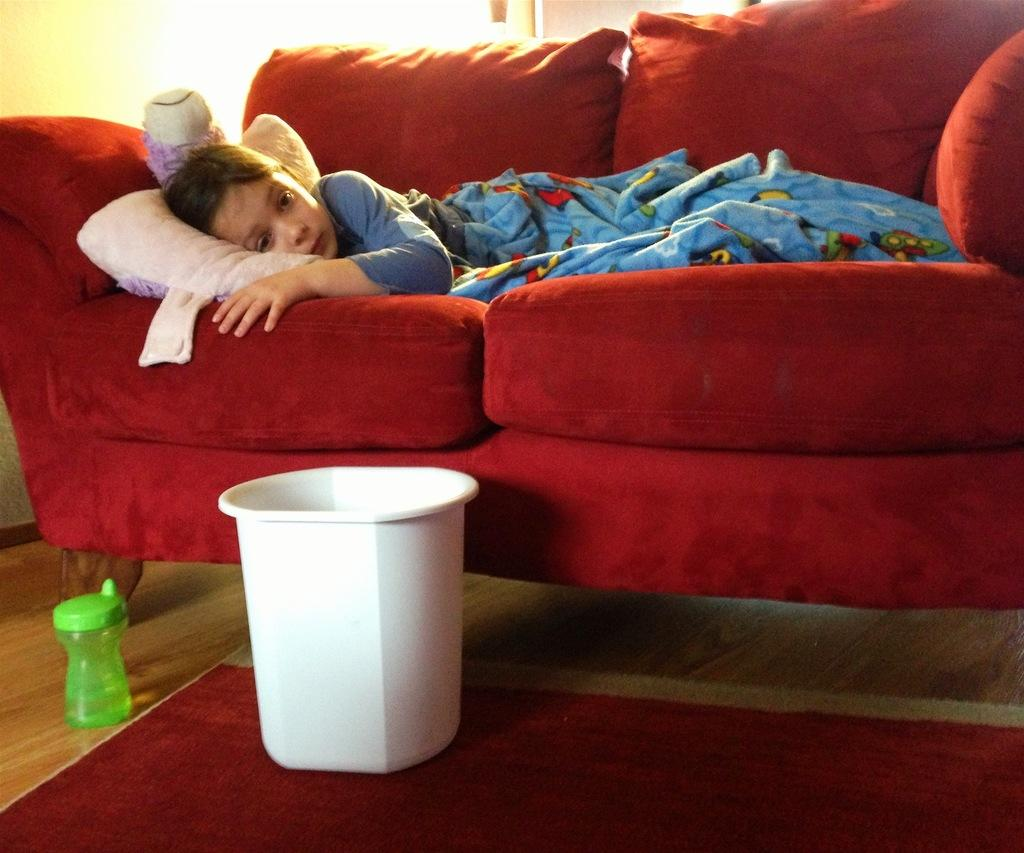What is the girl doing in the image? The girl is sleeping on a couch in the image. What object can be seen near the couch? There is a dustbin in the image. What item is visible that might be used for hydration? There is a water bottle in the image. What object is present that might provide comfort while sleeping? There is a pillow in the image. What type of war is being depicted in the image? There is no depiction of war in the image; it features a girl sleeping on a couch. How many people are present in the crowd in the image? There is no crowd present in the image; it only shows a girl sleeping on a couch. 